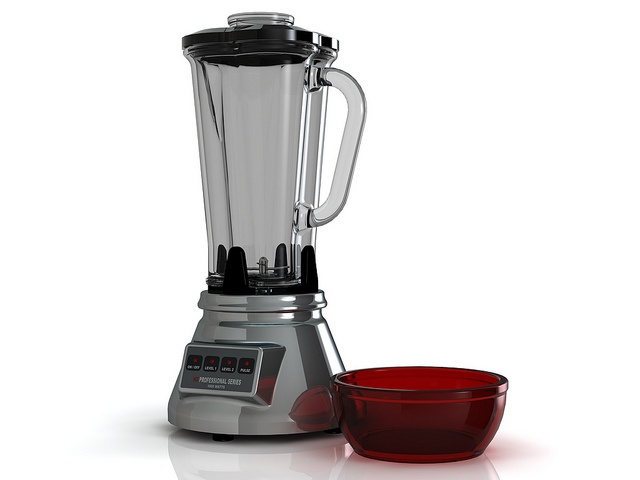Describe the objects in this image and their specific colors. I can see a bowl in white, black, maroon, and gray tones in this image. 